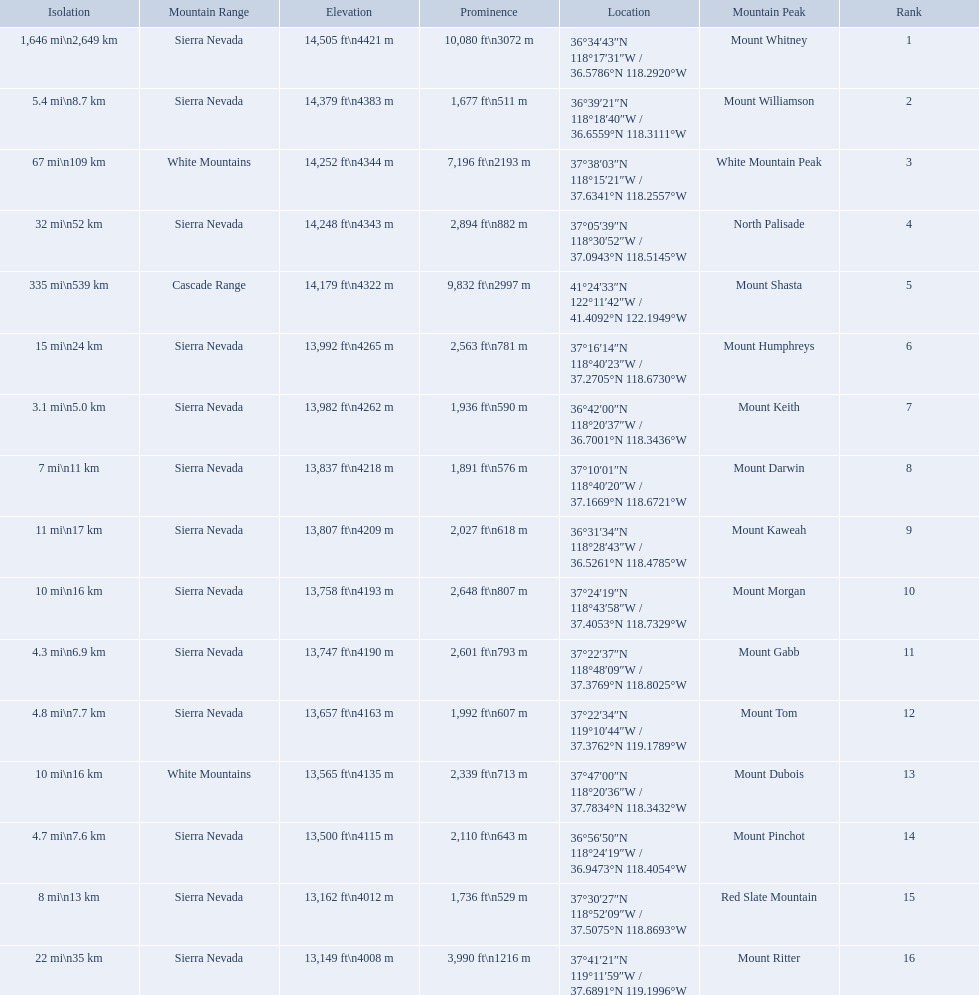What are the peaks in california? Mount Whitney, Mount Williamson, White Mountain Peak, North Palisade, Mount Shasta, Mount Humphreys, Mount Keith, Mount Darwin, Mount Kaweah, Mount Morgan, Mount Gabb, Mount Tom, Mount Dubois, Mount Pinchot, Red Slate Mountain, Mount Ritter. What are the peaks in sierra nevada, california? Mount Whitney, Mount Williamson, North Palisade, Mount Humphreys, Mount Keith, Mount Darwin, Mount Kaweah, Mount Morgan, Mount Gabb, Mount Tom, Mount Pinchot, Red Slate Mountain, Mount Ritter. What are the heights of the peaks in sierra nevada? 14,505 ft\n4421 m, 14,379 ft\n4383 m, 14,248 ft\n4343 m, 13,992 ft\n4265 m, 13,982 ft\n4262 m, 13,837 ft\n4218 m, 13,807 ft\n4209 m, 13,758 ft\n4193 m, 13,747 ft\n4190 m, 13,657 ft\n4163 m, 13,500 ft\n4115 m, 13,162 ft\n4012 m, 13,149 ft\n4008 m. Which is the highest? Mount Whitney. What are the mountain peaks? Mount Whitney, Mount Williamson, White Mountain Peak, North Palisade, Mount Shasta, Mount Humphreys, Mount Keith, Mount Darwin, Mount Kaweah, Mount Morgan, Mount Gabb, Mount Tom, Mount Dubois, Mount Pinchot, Red Slate Mountain, Mount Ritter. Of these, which one has a prominence more than 10,000 ft? Mount Whitney. Which are the highest mountain peaks in california? Mount Whitney, Mount Williamson, White Mountain Peak, North Palisade, Mount Shasta, Mount Humphreys, Mount Keith, Mount Darwin, Mount Kaweah, Mount Morgan, Mount Gabb, Mount Tom, Mount Dubois, Mount Pinchot, Red Slate Mountain, Mount Ritter. Of those, which are not in the sierra nevada range? White Mountain Peak, Mount Shasta, Mount Dubois. Of the mountains not in the sierra nevada range, which is the only mountain in the cascades? Mount Shasta. 